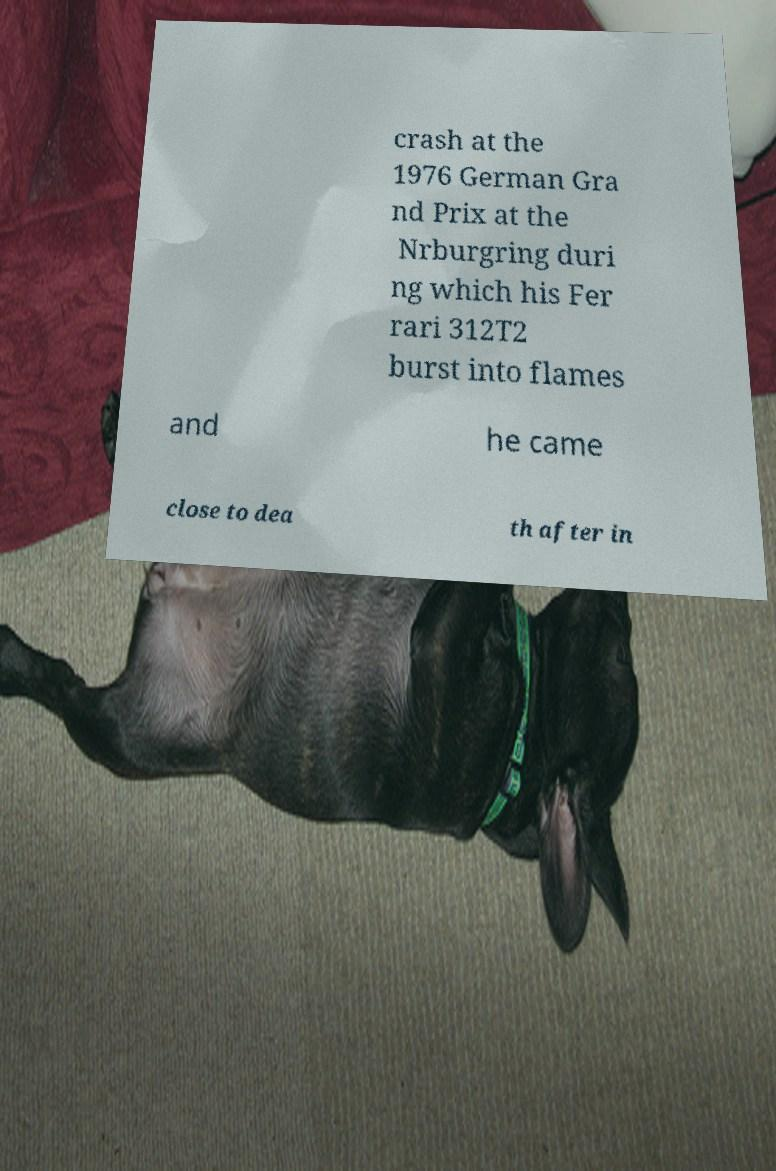Can you read and provide the text displayed in the image?This photo seems to have some interesting text. Can you extract and type it out for me? crash at the 1976 German Gra nd Prix at the Nrburgring duri ng which his Fer rari 312T2 burst into flames and he came close to dea th after in 